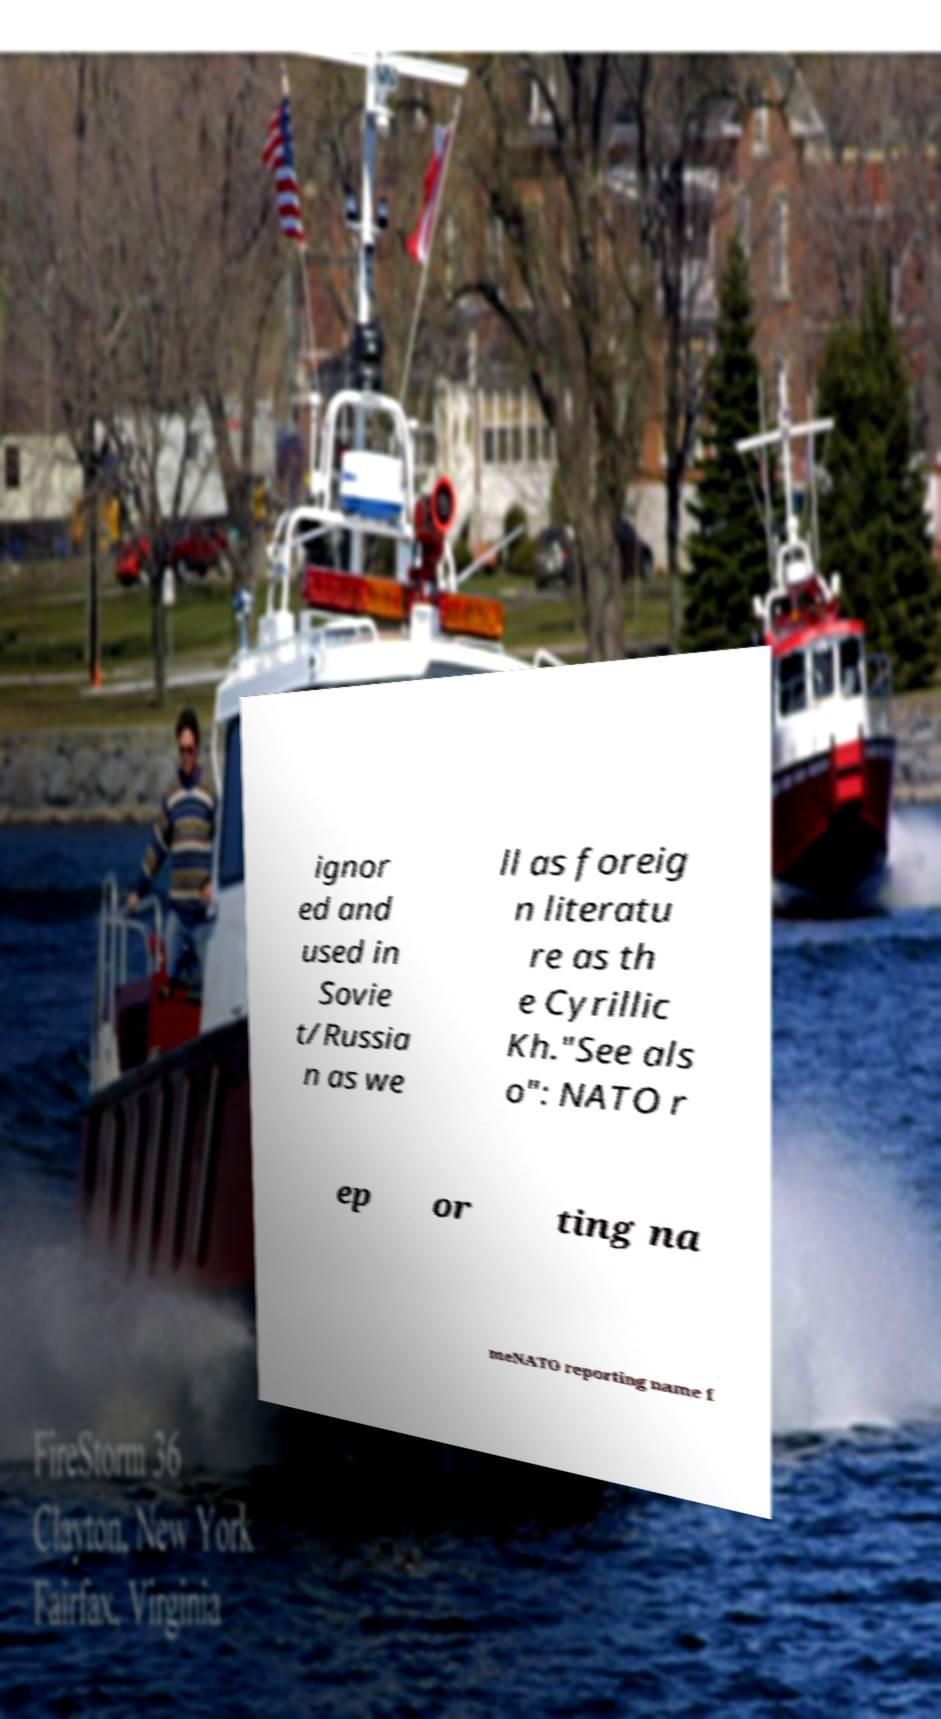Could you extract and type out the text from this image? ignor ed and used in Sovie t/Russia n as we ll as foreig n literatu re as th e Cyrillic Kh."See als o": NATO r ep or ting na meNATO reporting name f 